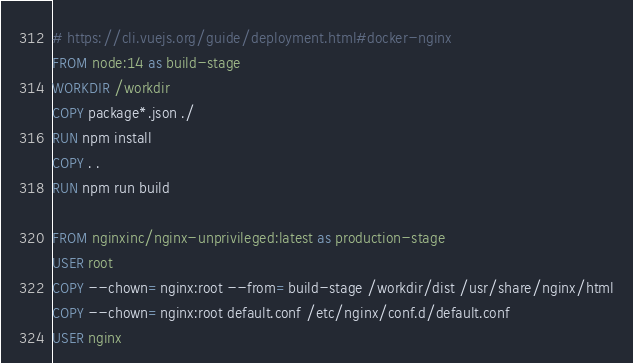Convert code to text. <code><loc_0><loc_0><loc_500><loc_500><_Dockerfile_># https://cli.vuejs.org/guide/deployment.html#docker-nginx
FROM node:14 as build-stage
WORKDIR /workdir
COPY package*.json ./
RUN npm install
COPY . .
RUN npm run build

FROM nginxinc/nginx-unprivileged:latest as production-stage
USER root
COPY --chown=nginx:root --from=build-stage /workdir/dist /usr/share/nginx/html
COPY --chown=nginx:root default.conf /etc/nginx/conf.d/default.conf
USER nginx
</code> 